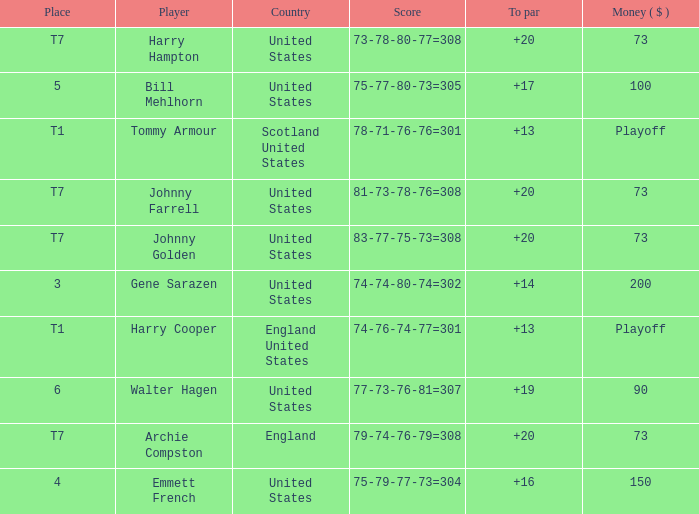What is the score for the United States when Harry Hampton is the player and the money is $73? 73-78-80-77=308. 